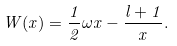<formula> <loc_0><loc_0><loc_500><loc_500>W ( x ) = \frac { 1 } { 2 } \omega x - \frac { l + 1 } { x } .</formula> 